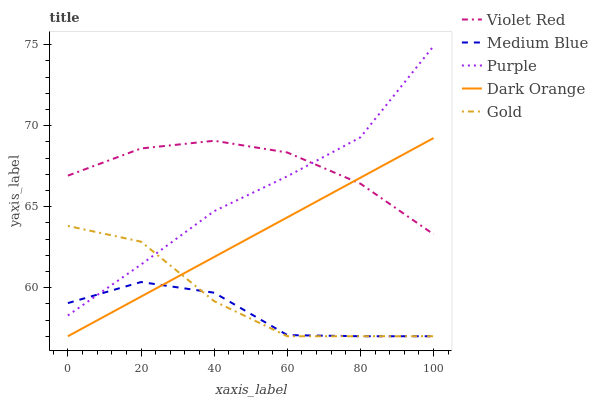Does Medium Blue have the minimum area under the curve?
Answer yes or no. Yes. Does Violet Red have the maximum area under the curve?
Answer yes or no. Yes. Does Dark Orange have the minimum area under the curve?
Answer yes or no. No. Does Dark Orange have the maximum area under the curve?
Answer yes or no. No. Is Dark Orange the smoothest?
Answer yes or no. Yes. Is Medium Blue the roughest?
Answer yes or no. Yes. Is Violet Red the smoothest?
Answer yes or no. No. Is Violet Red the roughest?
Answer yes or no. No. Does Dark Orange have the lowest value?
Answer yes or no. Yes. Does Violet Red have the lowest value?
Answer yes or no. No. Does Purple have the highest value?
Answer yes or no. Yes. Does Dark Orange have the highest value?
Answer yes or no. No. Is Medium Blue less than Violet Red?
Answer yes or no. Yes. Is Purple greater than Dark Orange?
Answer yes or no. Yes. Does Gold intersect Dark Orange?
Answer yes or no. Yes. Is Gold less than Dark Orange?
Answer yes or no. No. Is Gold greater than Dark Orange?
Answer yes or no. No. Does Medium Blue intersect Violet Red?
Answer yes or no. No. 